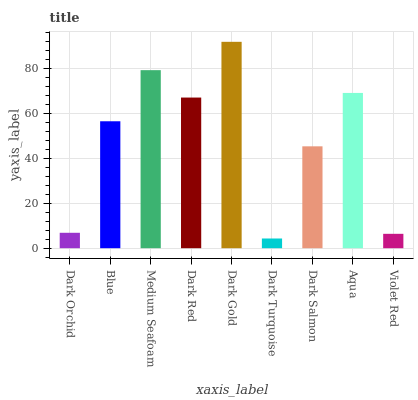Is Blue the minimum?
Answer yes or no. No. Is Blue the maximum?
Answer yes or no. No. Is Blue greater than Dark Orchid?
Answer yes or no. Yes. Is Dark Orchid less than Blue?
Answer yes or no. Yes. Is Dark Orchid greater than Blue?
Answer yes or no. No. Is Blue less than Dark Orchid?
Answer yes or no. No. Is Blue the high median?
Answer yes or no. Yes. Is Blue the low median?
Answer yes or no. Yes. Is Dark Turquoise the high median?
Answer yes or no. No. Is Aqua the low median?
Answer yes or no. No. 